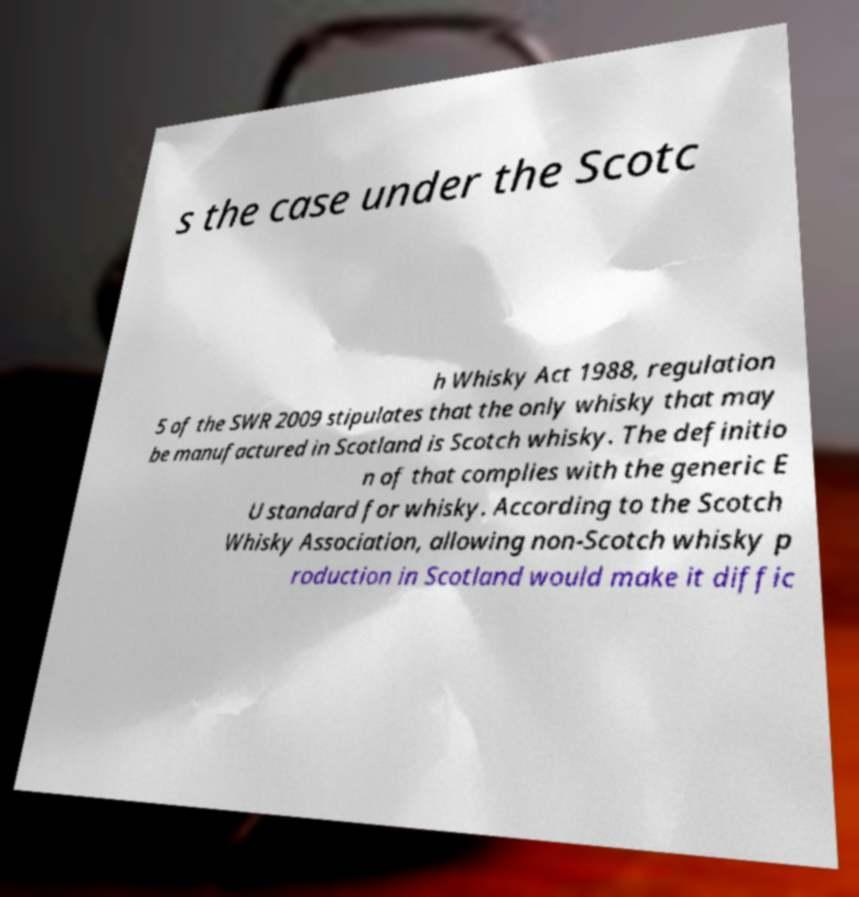Can you accurately transcribe the text from the provided image for me? s the case under the Scotc h Whisky Act 1988, regulation 5 of the SWR 2009 stipulates that the only whisky that may be manufactured in Scotland is Scotch whisky. The definitio n of that complies with the generic E U standard for whisky. According to the Scotch Whisky Association, allowing non-Scotch whisky p roduction in Scotland would make it diffic 